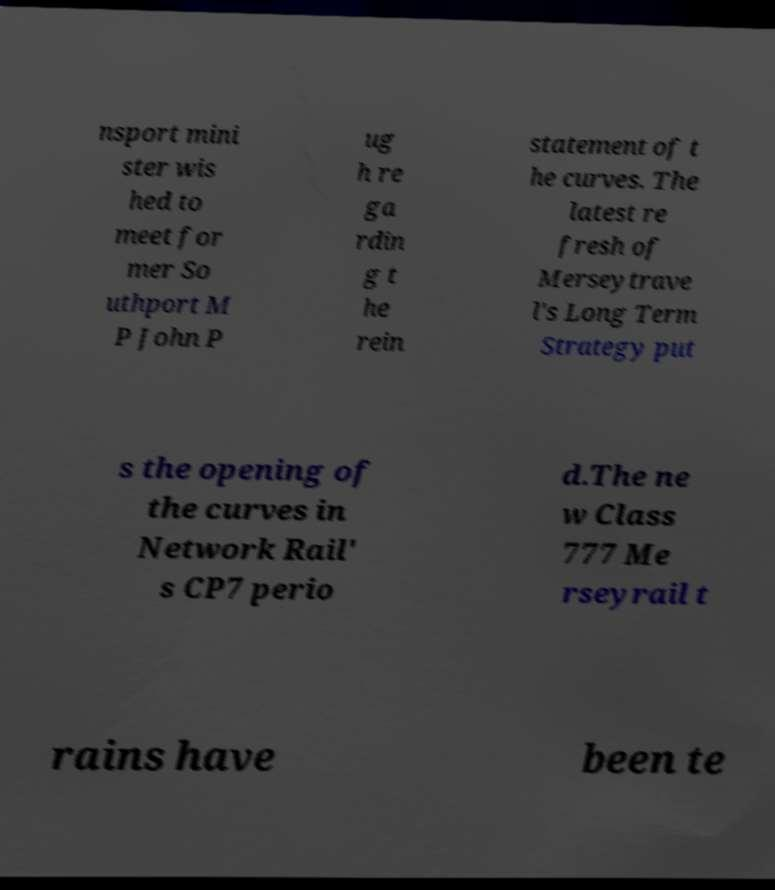Please identify and transcribe the text found in this image. nsport mini ster wis hed to meet for mer So uthport M P John P ug h re ga rdin g t he rein statement of t he curves. The latest re fresh of Merseytrave l's Long Term Strategy put s the opening of the curves in Network Rail' s CP7 perio d.The ne w Class 777 Me rseyrail t rains have been te 